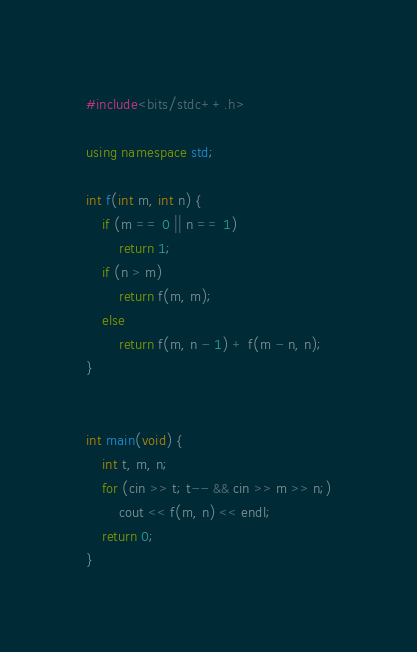Convert code to text. <code><loc_0><loc_0><loc_500><loc_500><_C++_>#include<bits/stdc++.h>

using namespace std;

int f(int m, int n) {
    if (m == 0 || n == 1)
        return 1;
    if (n > m)
        return f(m, m);
    else
        return f(m, n - 1) + f(m - n, n);
}


int main(void) {
    int t, m, n;
    for (cin >> t; t-- && cin >> m >> n;)
        cout << f(m, n) << endl;
    return 0;
}</code> 